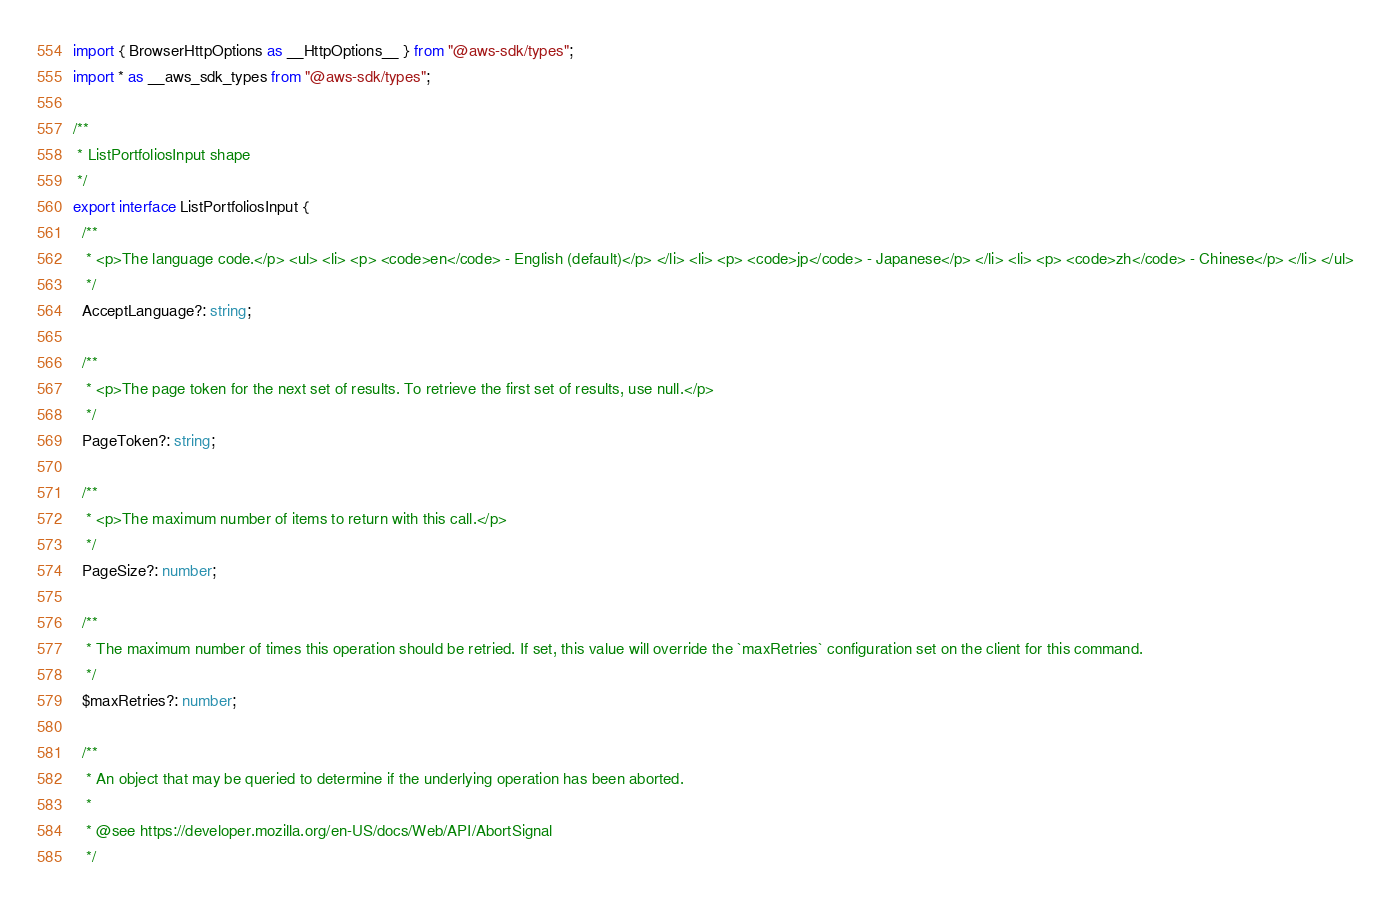Convert code to text. <code><loc_0><loc_0><loc_500><loc_500><_TypeScript_>import { BrowserHttpOptions as __HttpOptions__ } from "@aws-sdk/types";
import * as __aws_sdk_types from "@aws-sdk/types";

/**
 * ListPortfoliosInput shape
 */
export interface ListPortfoliosInput {
  /**
   * <p>The language code.</p> <ul> <li> <p> <code>en</code> - English (default)</p> </li> <li> <p> <code>jp</code> - Japanese</p> </li> <li> <p> <code>zh</code> - Chinese</p> </li> </ul>
   */
  AcceptLanguage?: string;

  /**
   * <p>The page token for the next set of results. To retrieve the first set of results, use null.</p>
   */
  PageToken?: string;

  /**
   * <p>The maximum number of items to return with this call.</p>
   */
  PageSize?: number;

  /**
   * The maximum number of times this operation should be retried. If set, this value will override the `maxRetries` configuration set on the client for this command.
   */
  $maxRetries?: number;

  /**
   * An object that may be queried to determine if the underlying operation has been aborted.
   *
   * @see https://developer.mozilla.org/en-US/docs/Web/API/AbortSignal
   */</code> 